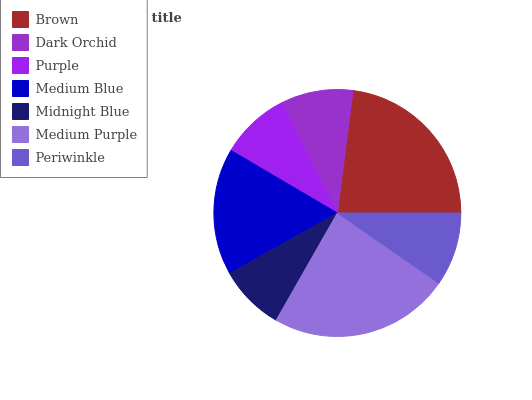Is Midnight Blue the minimum?
Answer yes or no. Yes. Is Medium Purple the maximum?
Answer yes or no. Yes. Is Dark Orchid the minimum?
Answer yes or no. No. Is Dark Orchid the maximum?
Answer yes or no. No. Is Brown greater than Dark Orchid?
Answer yes or no. Yes. Is Dark Orchid less than Brown?
Answer yes or no. Yes. Is Dark Orchid greater than Brown?
Answer yes or no. No. Is Brown less than Dark Orchid?
Answer yes or no. No. Is Periwinkle the high median?
Answer yes or no. Yes. Is Periwinkle the low median?
Answer yes or no. Yes. Is Dark Orchid the high median?
Answer yes or no. No. Is Medium Purple the low median?
Answer yes or no. No. 